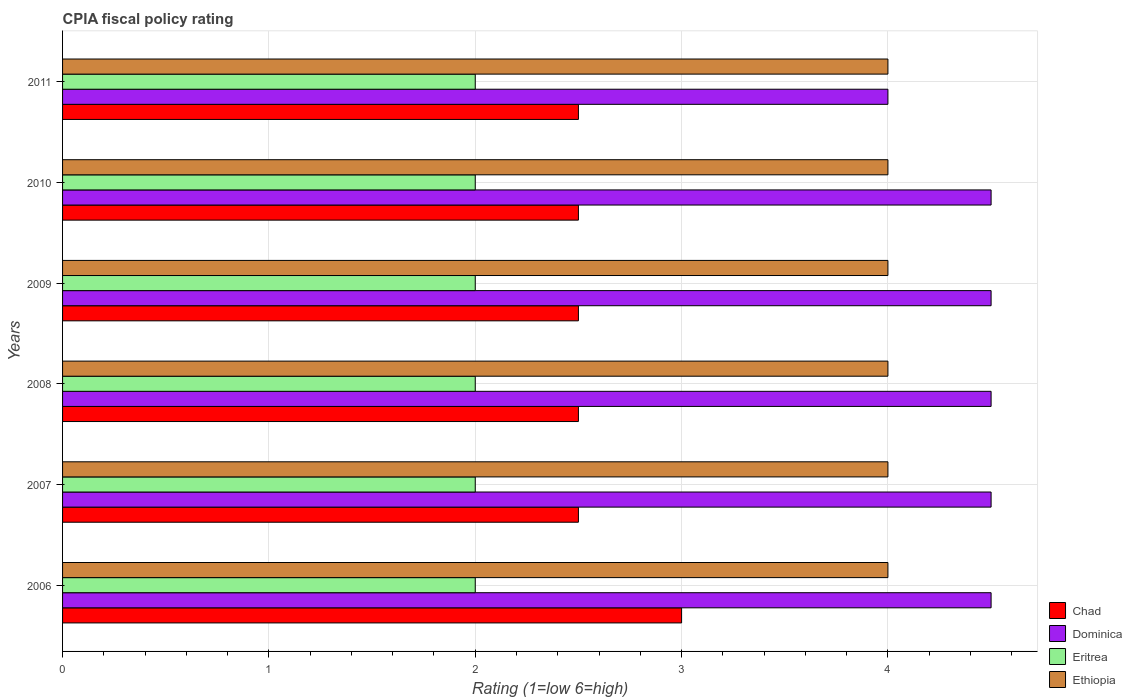How many different coloured bars are there?
Make the answer very short. 4. How many groups of bars are there?
Provide a short and direct response. 6. Are the number of bars on each tick of the Y-axis equal?
Provide a short and direct response. Yes. What is the label of the 5th group of bars from the top?
Give a very brief answer. 2007. Across all years, what is the minimum CPIA rating in Eritrea?
Your response must be concise. 2. In which year was the CPIA rating in Dominica maximum?
Your response must be concise. 2006. What is the difference between the CPIA rating in Dominica in 2006 and the CPIA rating in Ethiopia in 2011?
Your answer should be very brief. 0.5. What is the average CPIA rating in Ethiopia per year?
Your answer should be compact. 4. What is the ratio of the CPIA rating in Dominica in 2007 to that in 2010?
Your answer should be very brief. 1. In how many years, is the CPIA rating in Eritrea greater than the average CPIA rating in Eritrea taken over all years?
Your response must be concise. 0. Is the sum of the CPIA rating in Dominica in 2006 and 2008 greater than the maximum CPIA rating in Ethiopia across all years?
Keep it short and to the point. Yes. What does the 3rd bar from the top in 2009 represents?
Provide a succinct answer. Dominica. What does the 1st bar from the bottom in 2007 represents?
Your answer should be very brief. Chad. How many years are there in the graph?
Keep it short and to the point. 6. What is the difference between two consecutive major ticks on the X-axis?
Offer a terse response. 1. Are the values on the major ticks of X-axis written in scientific E-notation?
Your response must be concise. No. Does the graph contain grids?
Provide a succinct answer. Yes. How many legend labels are there?
Make the answer very short. 4. What is the title of the graph?
Provide a succinct answer. CPIA fiscal policy rating. Does "Mexico" appear as one of the legend labels in the graph?
Provide a short and direct response. No. What is the label or title of the X-axis?
Keep it short and to the point. Rating (1=low 6=high). What is the Rating (1=low 6=high) in Chad in 2006?
Offer a very short reply. 3. What is the Rating (1=low 6=high) of Dominica in 2006?
Keep it short and to the point. 4.5. What is the Rating (1=low 6=high) of Chad in 2007?
Give a very brief answer. 2.5. What is the Rating (1=low 6=high) in Dominica in 2007?
Keep it short and to the point. 4.5. What is the Rating (1=low 6=high) of Eritrea in 2007?
Ensure brevity in your answer.  2. What is the Rating (1=low 6=high) of Chad in 2008?
Offer a very short reply. 2.5. What is the Rating (1=low 6=high) of Ethiopia in 2009?
Your response must be concise. 4. What is the Rating (1=low 6=high) of Chad in 2010?
Keep it short and to the point. 2.5. What is the Rating (1=low 6=high) in Dominica in 2010?
Make the answer very short. 4.5. What is the Rating (1=low 6=high) in Ethiopia in 2010?
Provide a succinct answer. 4. What is the Rating (1=low 6=high) of Chad in 2011?
Your answer should be very brief. 2.5. What is the Rating (1=low 6=high) in Dominica in 2011?
Offer a very short reply. 4. What is the Rating (1=low 6=high) of Eritrea in 2011?
Provide a succinct answer. 2. What is the Rating (1=low 6=high) in Ethiopia in 2011?
Give a very brief answer. 4. Across all years, what is the maximum Rating (1=low 6=high) of Chad?
Provide a short and direct response. 3. Across all years, what is the maximum Rating (1=low 6=high) in Eritrea?
Your response must be concise. 2. Across all years, what is the minimum Rating (1=low 6=high) in Eritrea?
Provide a short and direct response. 2. What is the total Rating (1=low 6=high) in Chad in the graph?
Keep it short and to the point. 15.5. What is the total Rating (1=low 6=high) of Dominica in the graph?
Offer a very short reply. 26.5. What is the total Rating (1=low 6=high) of Eritrea in the graph?
Ensure brevity in your answer.  12. What is the total Rating (1=low 6=high) in Ethiopia in the graph?
Offer a terse response. 24. What is the difference between the Rating (1=low 6=high) in Chad in 2006 and that in 2007?
Your response must be concise. 0.5. What is the difference between the Rating (1=low 6=high) of Dominica in 2006 and that in 2007?
Your response must be concise. 0. What is the difference between the Rating (1=low 6=high) of Eritrea in 2006 and that in 2008?
Your answer should be very brief. 0. What is the difference between the Rating (1=low 6=high) in Ethiopia in 2006 and that in 2008?
Provide a short and direct response. 0. What is the difference between the Rating (1=low 6=high) in Chad in 2006 and that in 2009?
Give a very brief answer. 0.5. What is the difference between the Rating (1=low 6=high) in Ethiopia in 2006 and that in 2009?
Offer a very short reply. 0. What is the difference between the Rating (1=low 6=high) of Eritrea in 2006 and that in 2010?
Give a very brief answer. 0. What is the difference between the Rating (1=low 6=high) in Chad in 2006 and that in 2011?
Your response must be concise. 0.5. What is the difference between the Rating (1=low 6=high) of Eritrea in 2006 and that in 2011?
Provide a succinct answer. 0. What is the difference between the Rating (1=low 6=high) in Chad in 2007 and that in 2008?
Your answer should be very brief. 0. What is the difference between the Rating (1=low 6=high) in Dominica in 2007 and that in 2008?
Offer a terse response. 0. What is the difference between the Rating (1=low 6=high) of Eritrea in 2007 and that in 2008?
Ensure brevity in your answer.  0. What is the difference between the Rating (1=low 6=high) of Ethiopia in 2007 and that in 2008?
Ensure brevity in your answer.  0. What is the difference between the Rating (1=low 6=high) of Chad in 2007 and that in 2009?
Your response must be concise. 0. What is the difference between the Rating (1=low 6=high) of Dominica in 2007 and that in 2009?
Your answer should be very brief. 0. What is the difference between the Rating (1=low 6=high) of Eritrea in 2007 and that in 2009?
Your answer should be compact. 0. What is the difference between the Rating (1=low 6=high) of Chad in 2007 and that in 2010?
Ensure brevity in your answer.  0. What is the difference between the Rating (1=low 6=high) in Ethiopia in 2007 and that in 2010?
Offer a terse response. 0. What is the difference between the Rating (1=low 6=high) of Chad in 2007 and that in 2011?
Provide a succinct answer. 0. What is the difference between the Rating (1=low 6=high) in Eritrea in 2007 and that in 2011?
Your answer should be compact. 0. What is the difference between the Rating (1=low 6=high) in Chad in 2008 and that in 2009?
Your answer should be compact. 0. What is the difference between the Rating (1=low 6=high) of Dominica in 2008 and that in 2010?
Provide a succinct answer. 0. What is the difference between the Rating (1=low 6=high) in Chad in 2008 and that in 2011?
Provide a succinct answer. 0. What is the difference between the Rating (1=low 6=high) in Dominica in 2008 and that in 2011?
Provide a succinct answer. 0.5. What is the difference between the Rating (1=low 6=high) in Eritrea in 2008 and that in 2011?
Provide a short and direct response. 0. What is the difference between the Rating (1=low 6=high) of Chad in 2009 and that in 2010?
Provide a succinct answer. 0. What is the difference between the Rating (1=low 6=high) of Chad in 2009 and that in 2011?
Keep it short and to the point. 0. What is the difference between the Rating (1=low 6=high) in Chad in 2010 and that in 2011?
Your answer should be very brief. 0. What is the difference between the Rating (1=low 6=high) in Dominica in 2010 and that in 2011?
Provide a succinct answer. 0.5. What is the difference between the Rating (1=low 6=high) of Eritrea in 2010 and that in 2011?
Your answer should be very brief. 0. What is the difference between the Rating (1=low 6=high) in Dominica in 2006 and the Rating (1=low 6=high) in Eritrea in 2007?
Your answer should be very brief. 2.5. What is the difference between the Rating (1=low 6=high) in Dominica in 2006 and the Rating (1=low 6=high) in Ethiopia in 2007?
Your response must be concise. 0.5. What is the difference between the Rating (1=low 6=high) in Dominica in 2006 and the Rating (1=low 6=high) in Eritrea in 2008?
Offer a very short reply. 2.5. What is the difference between the Rating (1=low 6=high) of Chad in 2006 and the Rating (1=low 6=high) of Dominica in 2009?
Provide a short and direct response. -1.5. What is the difference between the Rating (1=low 6=high) in Chad in 2006 and the Rating (1=low 6=high) in Eritrea in 2009?
Your answer should be compact. 1. What is the difference between the Rating (1=low 6=high) of Chad in 2006 and the Rating (1=low 6=high) of Ethiopia in 2009?
Provide a succinct answer. -1. What is the difference between the Rating (1=low 6=high) in Dominica in 2006 and the Rating (1=low 6=high) in Eritrea in 2009?
Give a very brief answer. 2.5. What is the difference between the Rating (1=low 6=high) of Dominica in 2006 and the Rating (1=low 6=high) of Ethiopia in 2009?
Offer a terse response. 0.5. What is the difference between the Rating (1=low 6=high) in Eritrea in 2006 and the Rating (1=low 6=high) in Ethiopia in 2009?
Your response must be concise. -2. What is the difference between the Rating (1=low 6=high) in Chad in 2006 and the Rating (1=low 6=high) in Ethiopia in 2010?
Your answer should be very brief. -1. What is the difference between the Rating (1=low 6=high) in Chad in 2006 and the Rating (1=low 6=high) in Ethiopia in 2011?
Provide a short and direct response. -1. What is the difference between the Rating (1=low 6=high) of Dominica in 2006 and the Rating (1=low 6=high) of Ethiopia in 2011?
Your response must be concise. 0.5. What is the difference between the Rating (1=low 6=high) in Chad in 2007 and the Rating (1=low 6=high) in Dominica in 2008?
Ensure brevity in your answer.  -2. What is the difference between the Rating (1=low 6=high) of Dominica in 2007 and the Rating (1=low 6=high) of Eritrea in 2008?
Your answer should be very brief. 2.5. What is the difference between the Rating (1=low 6=high) in Eritrea in 2007 and the Rating (1=low 6=high) in Ethiopia in 2008?
Make the answer very short. -2. What is the difference between the Rating (1=low 6=high) in Dominica in 2007 and the Rating (1=low 6=high) in Ethiopia in 2009?
Provide a short and direct response. 0.5. What is the difference between the Rating (1=low 6=high) of Chad in 2007 and the Rating (1=low 6=high) of Dominica in 2010?
Provide a short and direct response. -2. What is the difference between the Rating (1=low 6=high) in Eritrea in 2007 and the Rating (1=low 6=high) in Ethiopia in 2010?
Keep it short and to the point. -2. What is the difference between the Rating (1=low 6=high) in Chad in 2007 and the Rating (1=low 6=high) in Eritrea in 2011?
Your response must be concise. 0.5. What is the difference between the Rating (1=low 6=high) of Chad in 2007 and the Rating (1=low 6=high) of Ethiopia in 2011?
Your answer should be compact. -1.5. What is the difference between the Rating (1=low 6=high) of Dominica in 2007 and the Rating (1=low 6=high) of Ethiopia in 2011?
Ensure brevity in your answer.  0.5. What is the difference between the Rating (1=low 6=high) in Eritrea in 2007 and the Rating (1=low 6=high) in Ethiopia in 2011?
Ensure brevity in your answer.  -2. What is the difference between the Rating (1=low 6=high) in Chad in 2008 and the Rating (1=low 6=high) in Eritrea in 2009?
Your response must be concise. 0.5. What is the difference between the Rating (1=low 6=high) of Chad in 2008 and the Rating (1=low 6=high) of Ethiopia in 2009?
Your answer should be very brief. -1.5. What is the difference between the Rating (1=low 6=high) in Dominica in 2008 and the Rating (1=low 6=high) in Eritrea in 2009?
Provide a short and direct response. 2.5. What is the difference between the Rating (1=low 6=high) of Eritrea in 2008 and the Rating (1=low 6=high) of Ethiopia in 2009?
Offer a terse response. -2. What is the difference between the Rating (1=low 6=high) in Chad in 2008 and the Rating (1=low 6=high) in Dominica in 2010?
Ensure brevity in your answer.  -2. What is the difference between the Rating (1=low 6=high) in Chad in 2008 and the Rating (1=low 6=high) in Eritrea in 2010?
Keep it short and to the point. 0.5. What is the difference between the Rating (1=low 6=high) in Chad in 2008 and the Rating (1=low 6=high) in Eritrea in 2011?
Your answer should be compact. 0.5. What is the difference between the Rating (1=low 6=high) in Chad in 2008 and the Rating (1=low 6=high) in Ethiopia in 2011?
Your answer should be compact. -1.5. What is the difference between the Rating (1=low 6=high) in Dominica in 2008 and the Rating (1=low 6=high) in Eritrea in 2011?
Make the answer very short. 2.5. What is the difference between the Rating (1=low 6=high) of Dominica in 2008 and the Rating (1=low 6=high) of Ethiopia in 2011?
Give a very brief answer. 0.5. What is the difference between the Rating (1=low 6=high) in Chad in 2009 and the Rating (1=low 6=high) in Dominica in 2010?
Your answer should be very brief. -2. What is the difference between the Rating (1=low 6=high) in Chad in 2009 and the Rating (1=low 6=high) in Ethiopia in 2010?
Make the answer very short. -1.5. What is the difference between the Rating (1=low 6=high) in Chad in 2009 and the Rating (1=low 6=high) in Eritrea in 2011?
Your answer should be compact. 0.5. What is the difference between the Rating (1=low 6=high) of Chad in 2009 and the Rating (1=low 6=high) of Ethiopia in 2011?
Keep it short and to the point. -1.5. What is the difference between the Rating (1=low 6=high) of Chad in 2010 and the Rating (1=low 6=high) of Dominica in 2011?
Your answer should be very brief. -1.5. What is the difference between the Rating (1=low 6=high) of Chad in 2010 and the Rating (1=low 6=high) of Eritrea in 2011?
Your response must be concise. 0.5. What is the difference between the Rating (1=low 6=high) of Dominica in 2010 and the Rating (1=low 6=high) of Eritrea in 2011?
Offer a very short reply. 2.5. What is the difference between the Rating (1=low 6=high) of Eritrea in 2010 and the Rating (1=low 6=high) of Ethiopia in 2011?
Ensure brevity in your answer.  -2. What is the average Rating (1=low 6=high) in Chad per year?
Your answer should be very brief. 2.58. What is the average Rating (1=low 6=high) of Dominica per year?
Provide a short and direct response. 4.42. What is the average Rating (1=low 6=high) in Eritrea per year?
Provide a succinct answer. 2. What is the average Rating (1=low 6=high) of Ethiopia per year?
Your answer should be compact. 4. In the year 2006, what is the difference between the Rating (1=low 6=high) of Chad and Rating (1=low 6=high) of Dominica?
Offer a very short reply. -1.5. In the year 2006, what is the difference between the Rating (1=low 6=high) in Chad and Rating (1=low 6=high) in Eritrea?
Give a very brief answer. 1. In the year 2006, what is the difference between the Rating (1=low 6=high) in Dominica and Rating (1=low 6=high) in Eritrea?
Your response must be concise. 2.5. In the year 2006, what is the difference between the Rating (1=low 6=high) of Dominica and Rating (1=low 6=high) of Ethiopia?
Your response must be concise. 0.5. In the year 2007, what is the difference between the Rating (1=low 6=high) in Chad and Rating (1=low 6=high) in Eritrea?
Offer a very short reply. 0.5. In the year 2007, what is the difference between the Rating (1=low 6=high) in Dominica and Rating (1=low 6=high) in Ethiopia?
Ensure brevity in your answer.  0.5. In the year 2008, what is the difference between the Rating (1=low 6=high) of Chad and Rating (1=low 6=high) of Dominica?
Make the answer very short. -2. In the year 2009, what is the difference between the Rating (1=low 6=high) in Chad and Rating (1=low 6=high) in Eritrea?
Keep it short and to the point. 0.5. In the year 2009, what is the difference between the Rating (1=low 6=high) in Chad and Rating (1=low 6=high) in Ethiopia?
Provide a short and direct response. -1.5. In the year 2009, what is the difference between the Rating (1=low 6=high) in Dominica and Rating (1=low 6=high) in Eritrea?
Provide a succinct answer. 2.5. In the year 2009, what is the difference between the Rating (1=low 6=high) in Eritrea and Rating (1=low 6=high) in Ethiopia?
Provide a succinct answer. -2. In the year 2010, what is the difference between the Rating (1=low 6=high) in Chad and Rating (1=low 6=high) in Eritrea?
Keep it short and to the point. 0.5. In the year 2010, what is the difference between the Rating (1=low 6=high) in Chad and Rating (1=low 6=high) in Ethiopia?
Your answer should be very brief. -1.5. In the year 2010, what is the difference between the Rating (1=low 6=high) of Eritrea and Rating (1=low 6=high) of Ethiopia?
Ensure brevity in your answer.  -2. In the year 2011, what is the difference between the Rating (1=low 6=high) of Chad and Rating (1=low 6=high) of Dominica?
Ensure brevity in your answer.  -1.5. What is the ratio of the Rating (1=low 6=high) of Eritrea in 2006 to that in 2007?
Offer a terse response. 1. What is the ratio of the Rating (1=low 6=high) in Ethiopia in 2006 to that in 2007?
Your answer should be very brief. 1. What is the ratio of the Rating (1=low 6=high) of Dominica in 2006 to that in 2008?
Ensure brevity in your answer.  1. What is the ratio of the Rating (1=low 6=high) in Eritrea in 2006 to that in 2008?
Offer a very short reply. 1. What is the ratio of the Rating (1=low 6=high) in Chad in 2006 to that in 2009?
Provide a succinct answer. 1.2. What is the ratio of the Rating (1=low 6=high) in Chad in 2006 to that in 2010?
Keep it short and to the point. 1.2. What is the ratio of the Rating (1=low 6=high) of Eritrea in 2006 to that in 2010?
Ensure brevity in your answer.  1. What is the ratio of the Rating (1=low 6=high) of Eritrea in 2006 to that in 2011?
Offer a very short reply. 1. What is the ratio of the Rating (1=low 6=high) in Dominica in 2007 to that in 2008?
Your response must be concise. 1. What is the ratio of the Rating (1=low 6=high) of Chad in 2007 to that in 2010?
Provide a succinct answer. 1. What is the ratio of the Rating (1=low 6=high) of Dominica in 2007 to that in 2010?
Your answer should be compact. 1. What is the ratio of the Rating (1=low 6=high) in Eritrea in 2007 to that in 2010?
Offer a terse response. 1. What is the ratio of the Rating (1=low 6=high) of Chad in 2007 to that in 2011?
Offer a terse response. 1. What is the ratio of the Rating (1=low 6=high) of Chad in 2008 to that in 2009?
Make the answer very short. 1. What is the ratio of the Rating (1=low 6=high) of Dominica in 2008 to that in 2009?
Provide a short and direct response. 1. What is the ratio of the Rating (1=low 6=high) in Dominica in 2008 to that in 2010?
Make the answer very short. 1. What is the ratio of the Rating (1=low 6=high) in Eritrea in 2008 to that in 2010?
Ensure brevity in your answer.  1. What is the ratio of the Rating (1=low 6=high) of Chad in 2008 to that in 2011?
Give a very brief answer. 1. What is the ratio of the Rating (1=low 6=high) in Eritrea in 2008 to that in 2011?
Offer a very short reply. 1. What is the ratio of the Rating (1=low 6=high) of Ethiopia in 2008 to that in 2011?
Provide a succinct answer. 1. What is the ratio of the Rating (1=low 6=high) in Eritrea in 2009 to that in 2010?
Your answer should be very brief. 1. What is the ratio of the Rating (1=low 6=high) of Ethiopia in 2009 to that in 2010?
Offer a very short reply. 1. What is the ratio of the Rating (1=low 6=high) in Chad in 2009 to that in 2011?
Your response must be concise. 1. What is the ratio of the Rating (1=low 6=high) of Ethiopia in 2009 to that in 2011?
Your answer should be very brief. 1. What is the ratio of the Rating (1=low 6=high) of Chad in 2010 to that in 2011?
Your answer should be compact. 1. What is the ratio of the Rating (1=low 6=high) in Dominica in 2010 to that in 2011?
Your response must be concise. 1.12. What is the difference between the highest and the lowest Rating (1=low 6=high) in Dominica?
Offer a terse response. 0.5. What is the difference between the highest and the lowest Rating (1=low 6=high) in Ethiopia?
Provide a short and direct response. 0. 